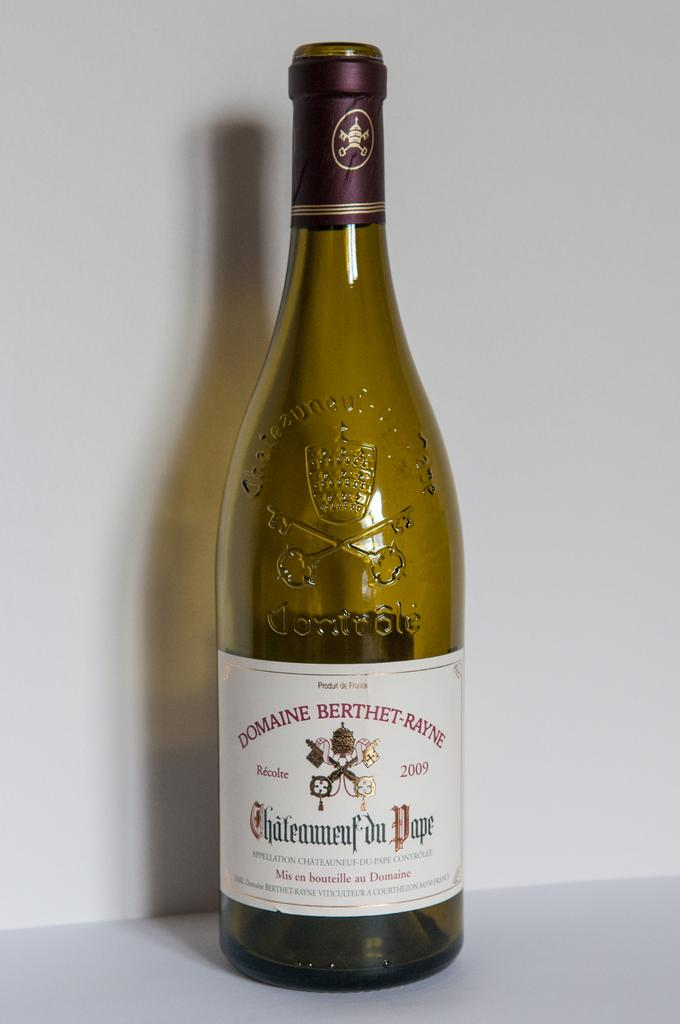<image>
Share a concise interpretation of the image provided. the word domaine is written on a bottle 